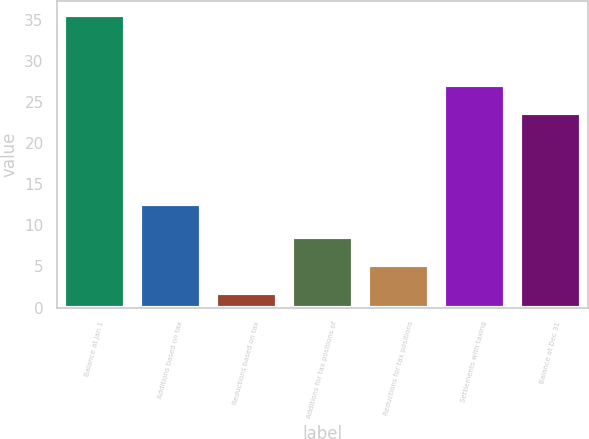<chart> <loc_0><loc_0><loc_500><loc_500><bar_chart><fcel>Balance at Jan 1<fcel>Additions based on tax<fcel>Reductions based on tax<fcel>Additions for tax positions of<fcel>Reductions for tax positions<fcel>Settlements with taxing<fcel>Balance at Dec 31<nl><fcel>35.5<fcel>12.6<fcel>1.8<fcel>8.54<fcel>5.17<fcel>27.1<fcel>23.7<nl></chart> 